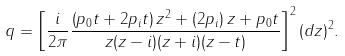<formula> <loc_0><loc_0><loc_500><loc_500>q = \left [ \frac { i } { 2 \pi } \frac { \left ( p _ { 0 } t + 2 p _ { i } t \right ) z ^ { 2 } + \left ( 2 p _ { i } \right ) z + p _ { 0 } t } { z ( z - i ) ( z + i ) ( z - t ) } \right ] ^ { 2 } ( d z ) ^ { 2 } .</formula> 